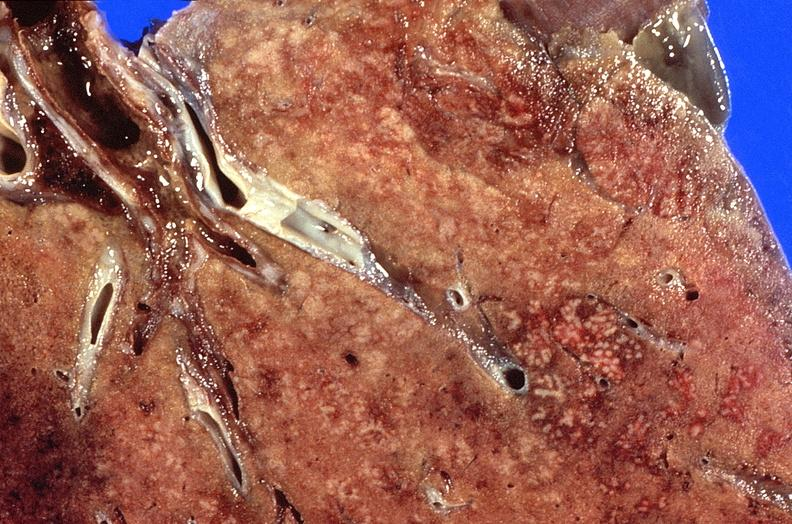does this image show lung, cyomegalovirus pneumonia?
Answer the question using a single word or phrase. Yes 